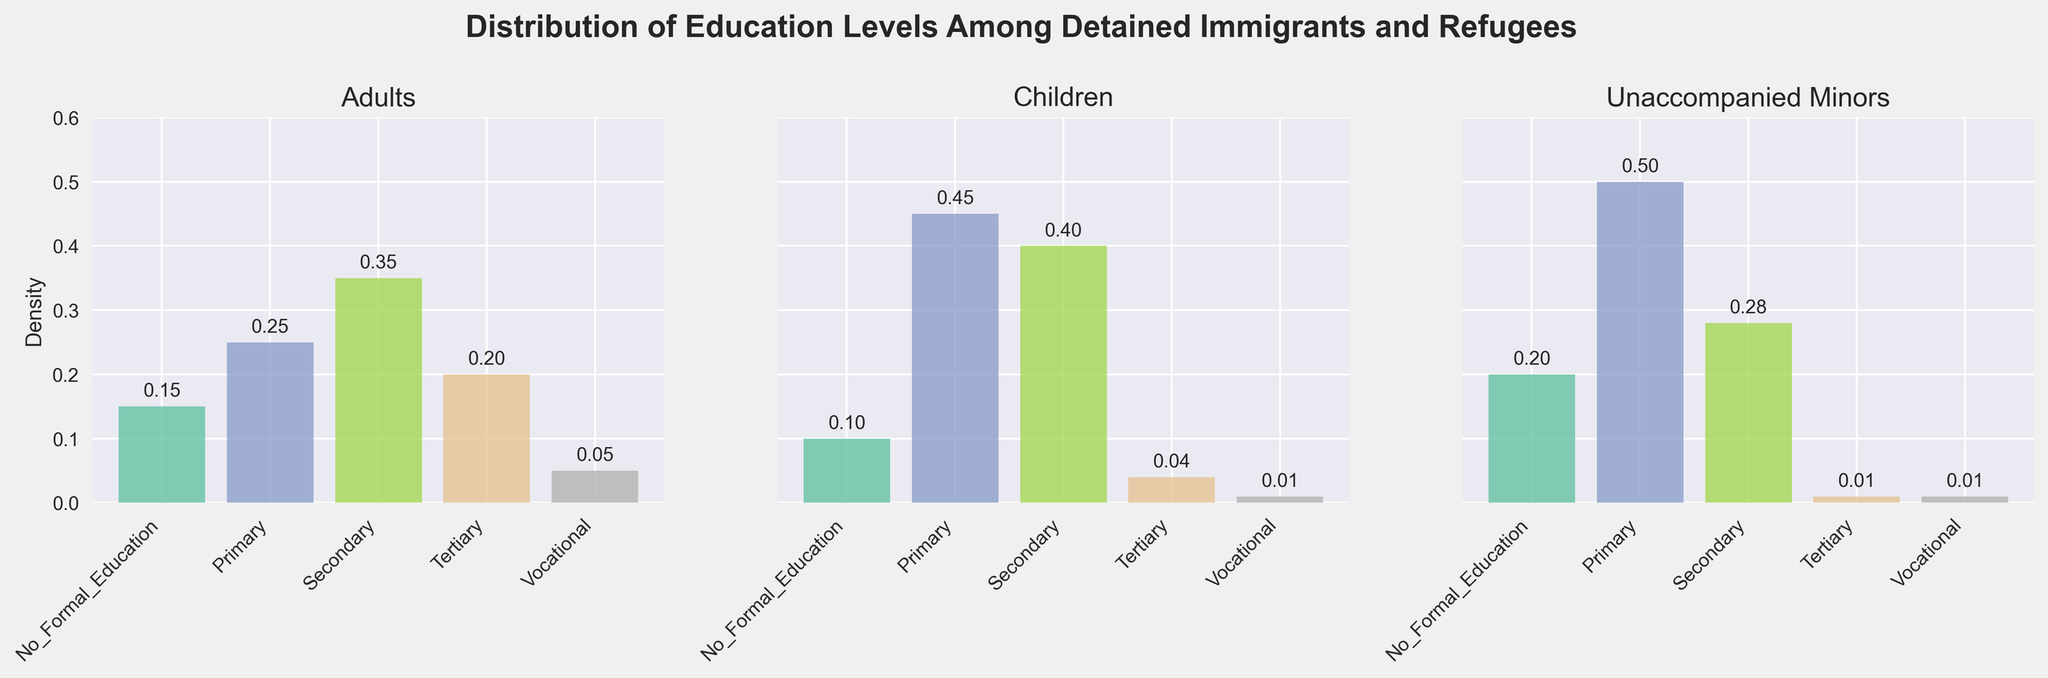What is the title of the figure? The title of the figure is located at the top-center of the plot, indicating what the entire plot is about.
Answer: Distribution of Education Levels Among Detained Immigrants and Refugees What is the density value for 'Primary' education level among Children? The density values for each education level are marked above the corresponding bars. To find the value for 'Primary' education level among Children, locate the bar labeled 'Primary' in the 'Children' subplot and check the value above it.
Answer: 0.45 Which group has the highest density for the 'Secondary' education level? Look at the bars labeled 'Secondary' across all three subplots. Compare the density values given above these bars and identify the highest one.
Answer: Adults What is the combined density of 'No Formal Education' across all groups? Sum the density values for 'No Formal Education' by adding the densities for Adults (0.15), Children (0.10), and Unaccompanied Minors (0.20).
Answer: 0.45 Which group has the least density for 'Tertiary' education level? Compare the density values for 'Tertiary' education level in all three subplots and identify the smallest one.
Answer: Unaccompanied Minors By how much does the density value for 'Vocational' education level differ between Adults and Children? Subtract the density value of 'Vocational' for Children (0.01) from that of Adults (0.05).
Answer: 0.04 What is the average density of 'Primary' education level across all groups? Calculate the average by adding the density values of 'Primary' education from Adults (0.25), Children (0.45), and Unaccompanied Minors (0.50), then divide by the number of groups (3). (0.25 + 0.45 + 0.50) / 3 = 1.20 / 3 = 0.40
Answer: 0.40 Which group exhibits the highest overall density of education levels? Sum the density values for all education levels in each group and compare the totals. 
For Adults: 0.15 + 0.25 + 0.35 + 0.20 + 0.05 = 1.00
For Children: 0.10 + 0.45 + 0.40 + 0.04 + 0.01 = 1.00
For Unaccompanied Minors: 0.20 + 0.50 + 0.28 + 0.01 + 0.01 = 1.00
All groups have the same overall density.
Answer: All groups have the same overall density 